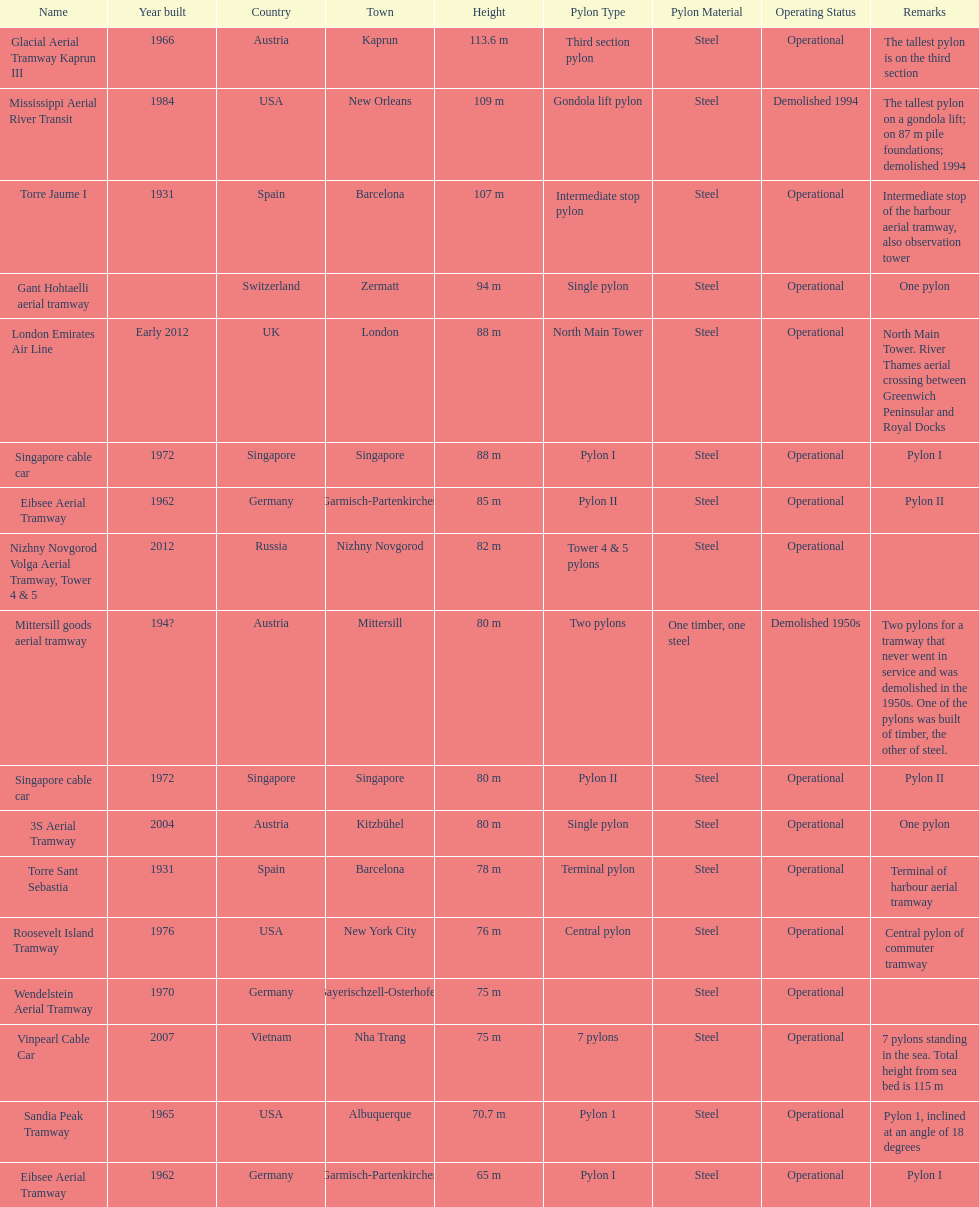How many pylons are in austria? 3. 